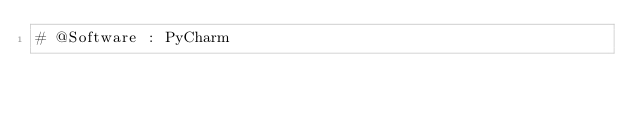<code> <loc_0><loc_0><loc_500><loc_500><_Python_># @Software : PyCharm
</code> 